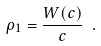<formula> <loc_0><loc_0><loc_500><loc_500>\rho _ { 1 } = \frac { W ( c ) } { c } \ .</formula> 